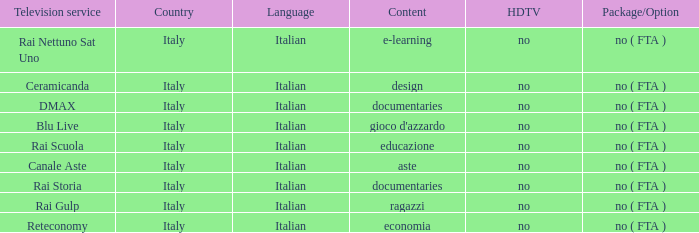What is the HDTV for the Rai Nettuno Sat Uno Television service? No. 